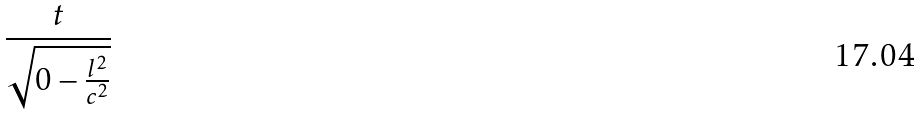Convert formula to latex. <formula><loc_0><loc_0><loc_500><loc_500>\frac { t } { \sqrt { 0 - \frac { l ^ { 2 } } { c ^ { 2 } } } }</formula> 